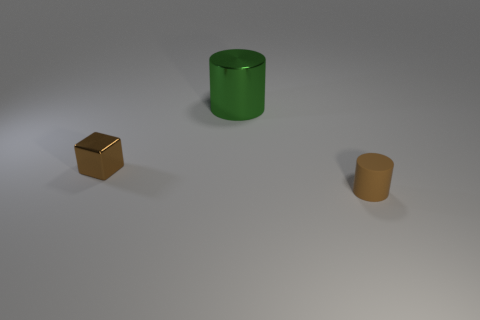Add 2 blue metal balls. How many objects exist? 5 Subtract all brown cylinders. How many cylinders are left? 1 Subtract 1 cylinders. How many cylinders are left? 1 Subtract all cylinders. How many objects are left? 1 Subtract 0 cyan blocks. How many objects are left? 3 Subtract all purple cylinders. Subtract all gray cubes. How many cylinders are left? 2 Subtract all brown matte things. Subtract all yellow rubber objects. How many objects are left? 2 Add 2 brown metallic objects. How many brown metallic objects are left? 3 Add 2 tiny brown rubber objects. How many tiny brown rubber objects exist? 3 